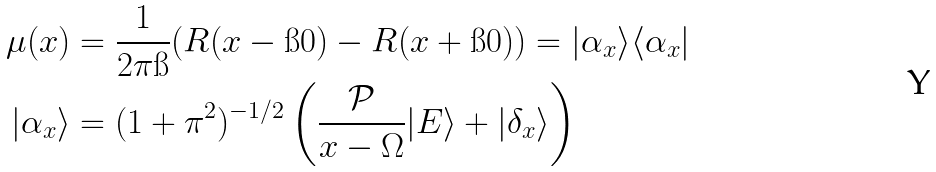<formula> <loc_0><loc_0><loc_500><loc_500>\mu ( x ) & = \frac { 1 } { 2 \pi \i } ( R ( x - \i 0 ) - R ( x + \i 0 ) ) = | \alpha _ { x } \rangle \langle \alpha _ { x } | \\ | \alpha _ { x } \rangle & = ( 1 + \pi ^ { 2 } ) ^ { - 1 / 2 } \left ( \frac { \mathcal { P } } { x - \Omega } | E \rangle + | \delta _ { x } \rangle \right )</formula> 